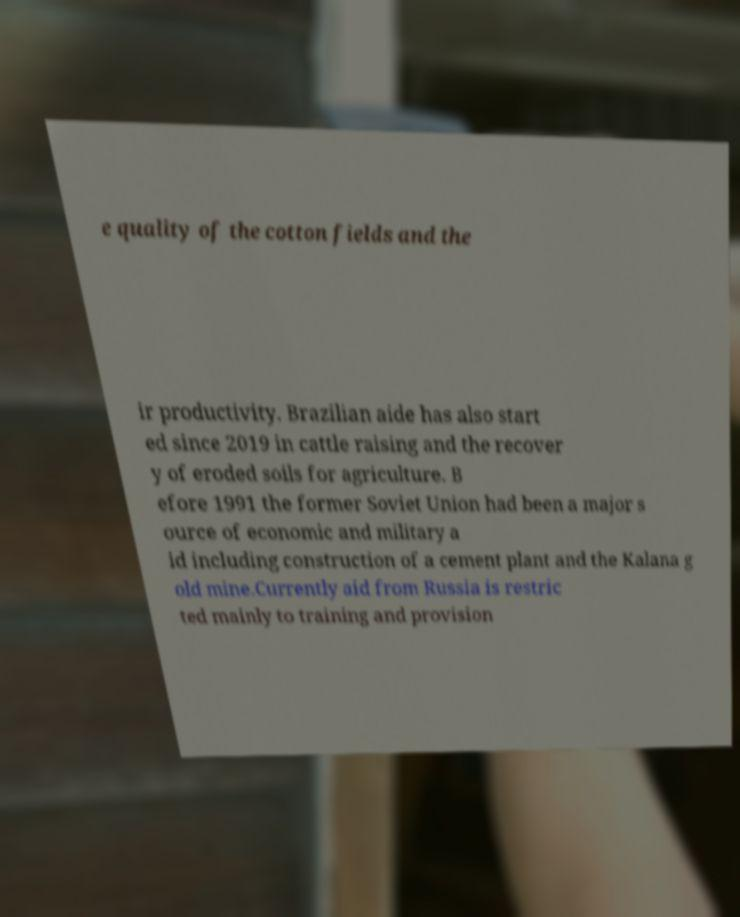Can you accurately transcribe the text from the provided image for me? e quality of the cotton fields and the ir productivity. Brazilian aide has also start ed since 2019 in cattle raising and the recover y of eroded soils for agriculture. B efore 1991 the former Soviet Union had been a major s ource of economic and military a id including construction of a cement plant and the Kalana g old mine.Currently aid from Russia is restric ted mainly to training and provision 